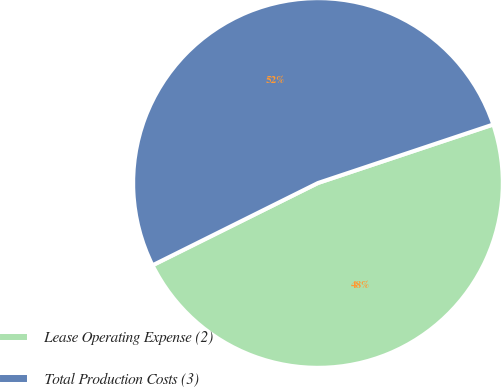<chart> <loc_0><loc_0><loc_500><loc_500><pie_chart><fcel>Lease Operating Expense (2)<fcel>Total Production Costs (3)<nl><fcel>47.78%<fcel>52.22%<nl></chart> 